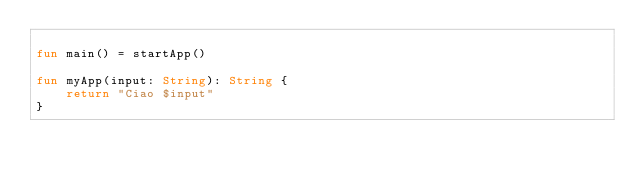Convert code to text. <code><loc_0><loc_0><loc_500><loc_500><_Kotlin_>
fun main() = startApp()

fun myApp(input: String): String {
    return "Ciao $input"
}</code> 